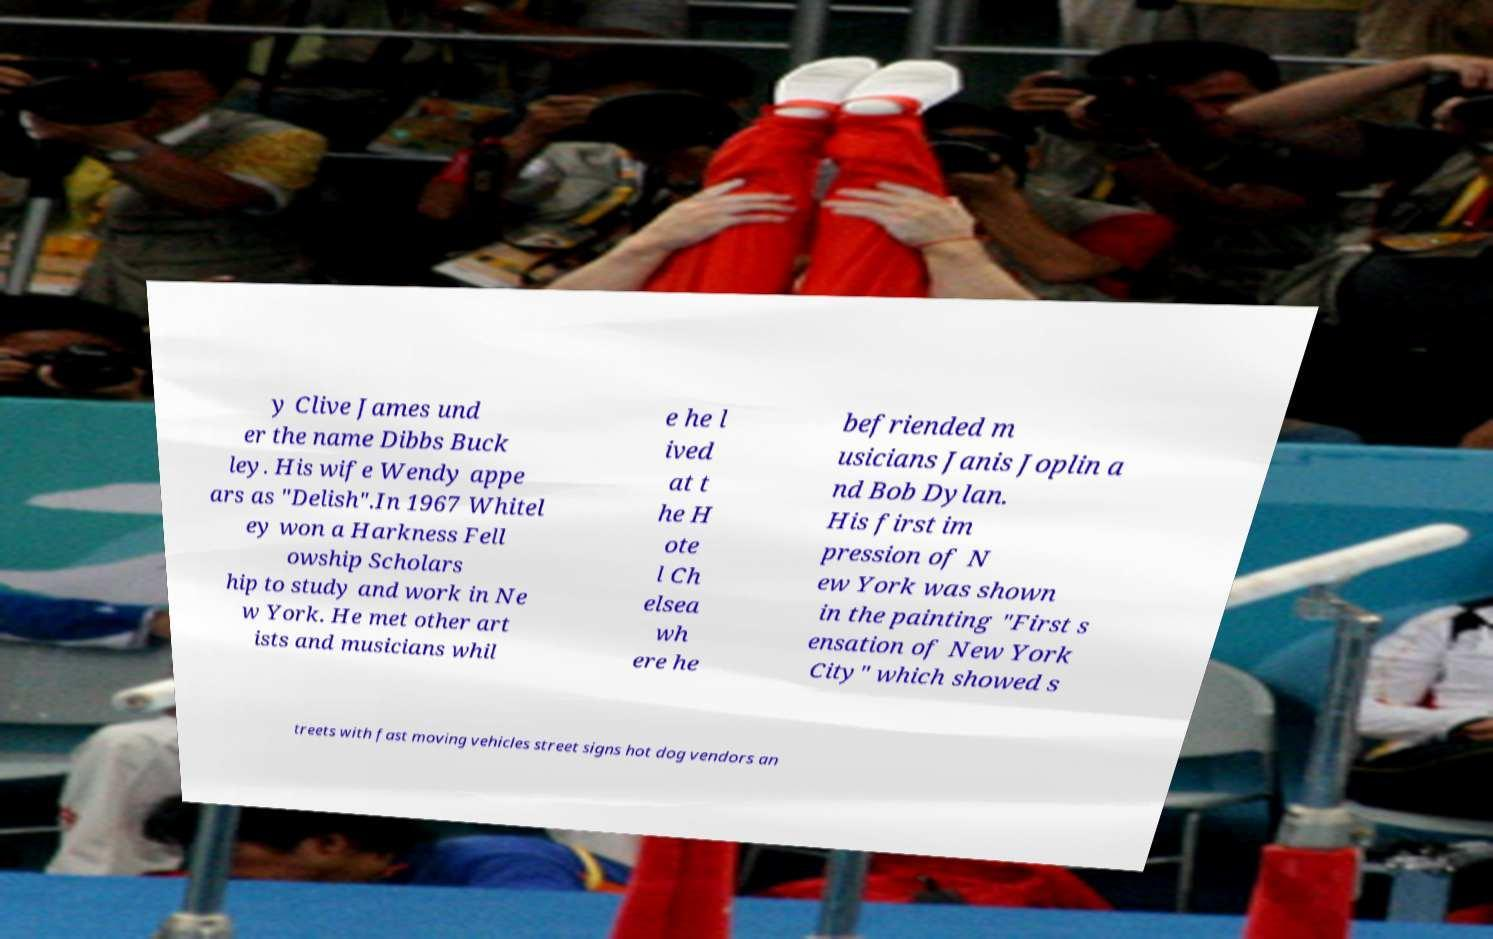Could you extract and type out the text from this image? y Clive James und er the name Dibbs Buck ley. His wife Wendy appe ars as "Delish".In 1967 Whitel ey won a Harkness Fell owship Scholars hip to study and work in Ne w York. He met other art ists and musicians whil e he l ived at t he H ote l Ch elsea wh ere he befriended m usicians Janis Joplin a nd Bob Dylan. His first im pression of N ew York was shown in the painting "First s ensation of New York City" which showed s treets with fast moving vehicles street signs hot dog vendors an 